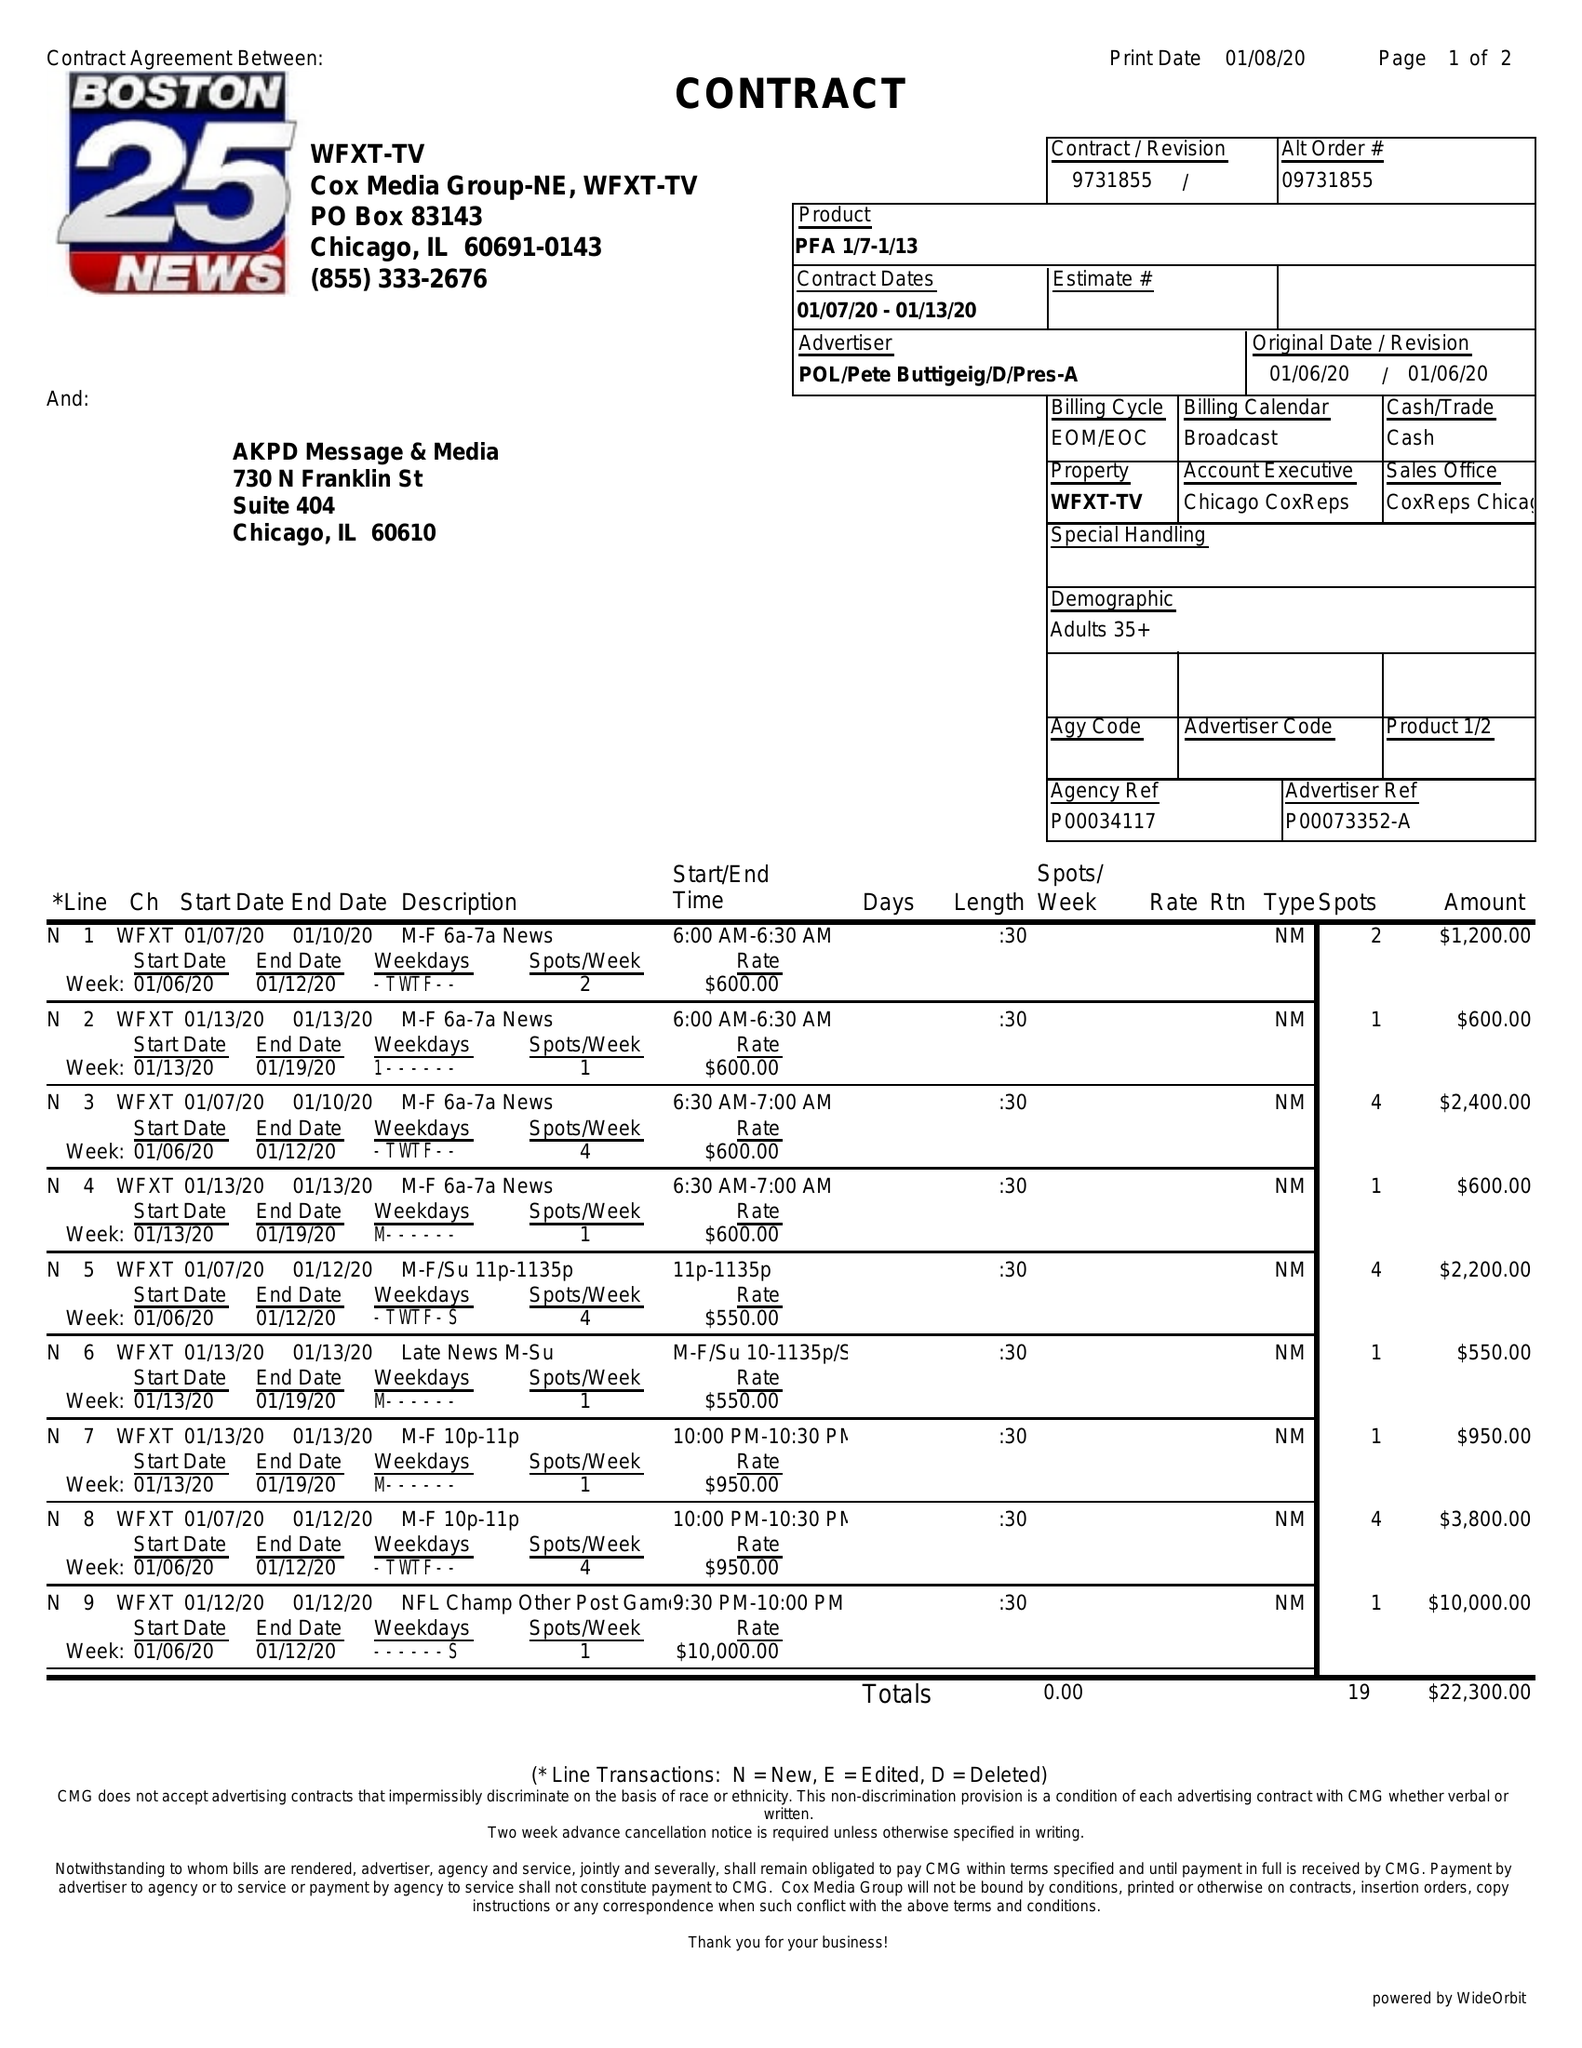What is the value for the gross_amount?
Answer the question using a single word or phrase. 22300.00 